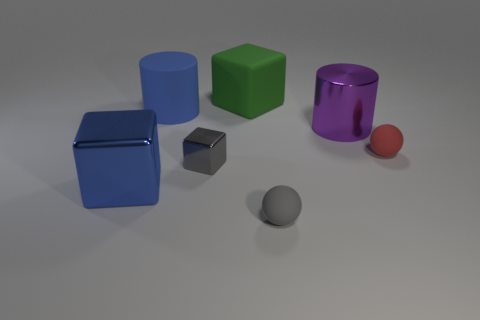Subtract all tiny cubes. How many cubes are left? 2 Subtract all green cubes. How many cubes are left? 2 Add 3 tiny metal objects. How many objects exist? 10 Subtract 1 blocks. How many blocks are left? 2 Subtract all brown cylinders. How many blue blocks are left? 1 Subtract 0 brown blocks. How many objects are left? 7 Subtract all blocks. How many objects are left? 4 Subtract all gray cylinders. Subtract all yellow cubes. How many cylinders are left? 2 Subtract all tiny purple rubber blocks. Subtract all blue cubes. How many objects are left? 6 Add 1 metal cylinders. How many metal cylinders are left? 2 